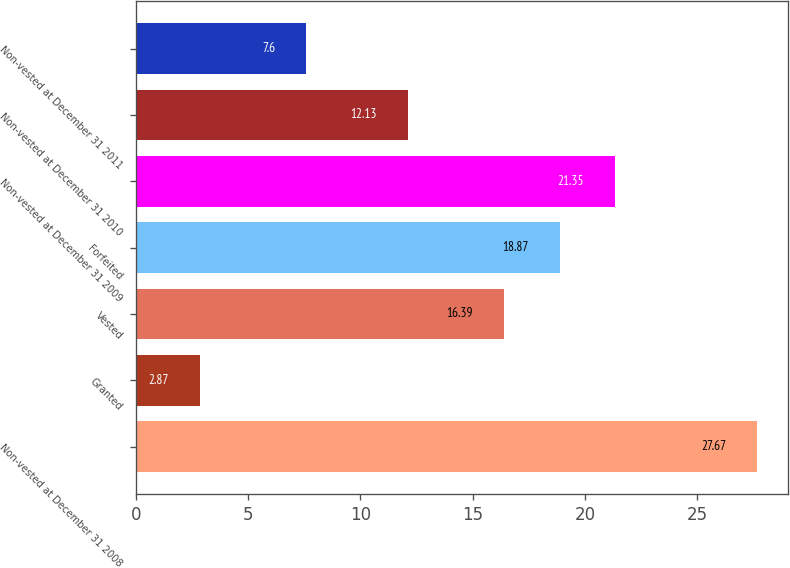Convert chart. <chart><loc_0><loc_0><loc_500><loc_500><bar_chart><fcel>Non-vested at December 31 2008<fcel>Granted<fcel>Vested<fcel>Forfeited<fcel>Non-vested at December 31 2009<fcel>Non-vested at December 31 2010<fcel>Non-vested at December 31 2011<nl><fcel>27.67<fcel>2.87<fcel>16.39<fcel>18.87<fcel>21.35<fcel>12.13<fcel>7.6<nl></chart> 